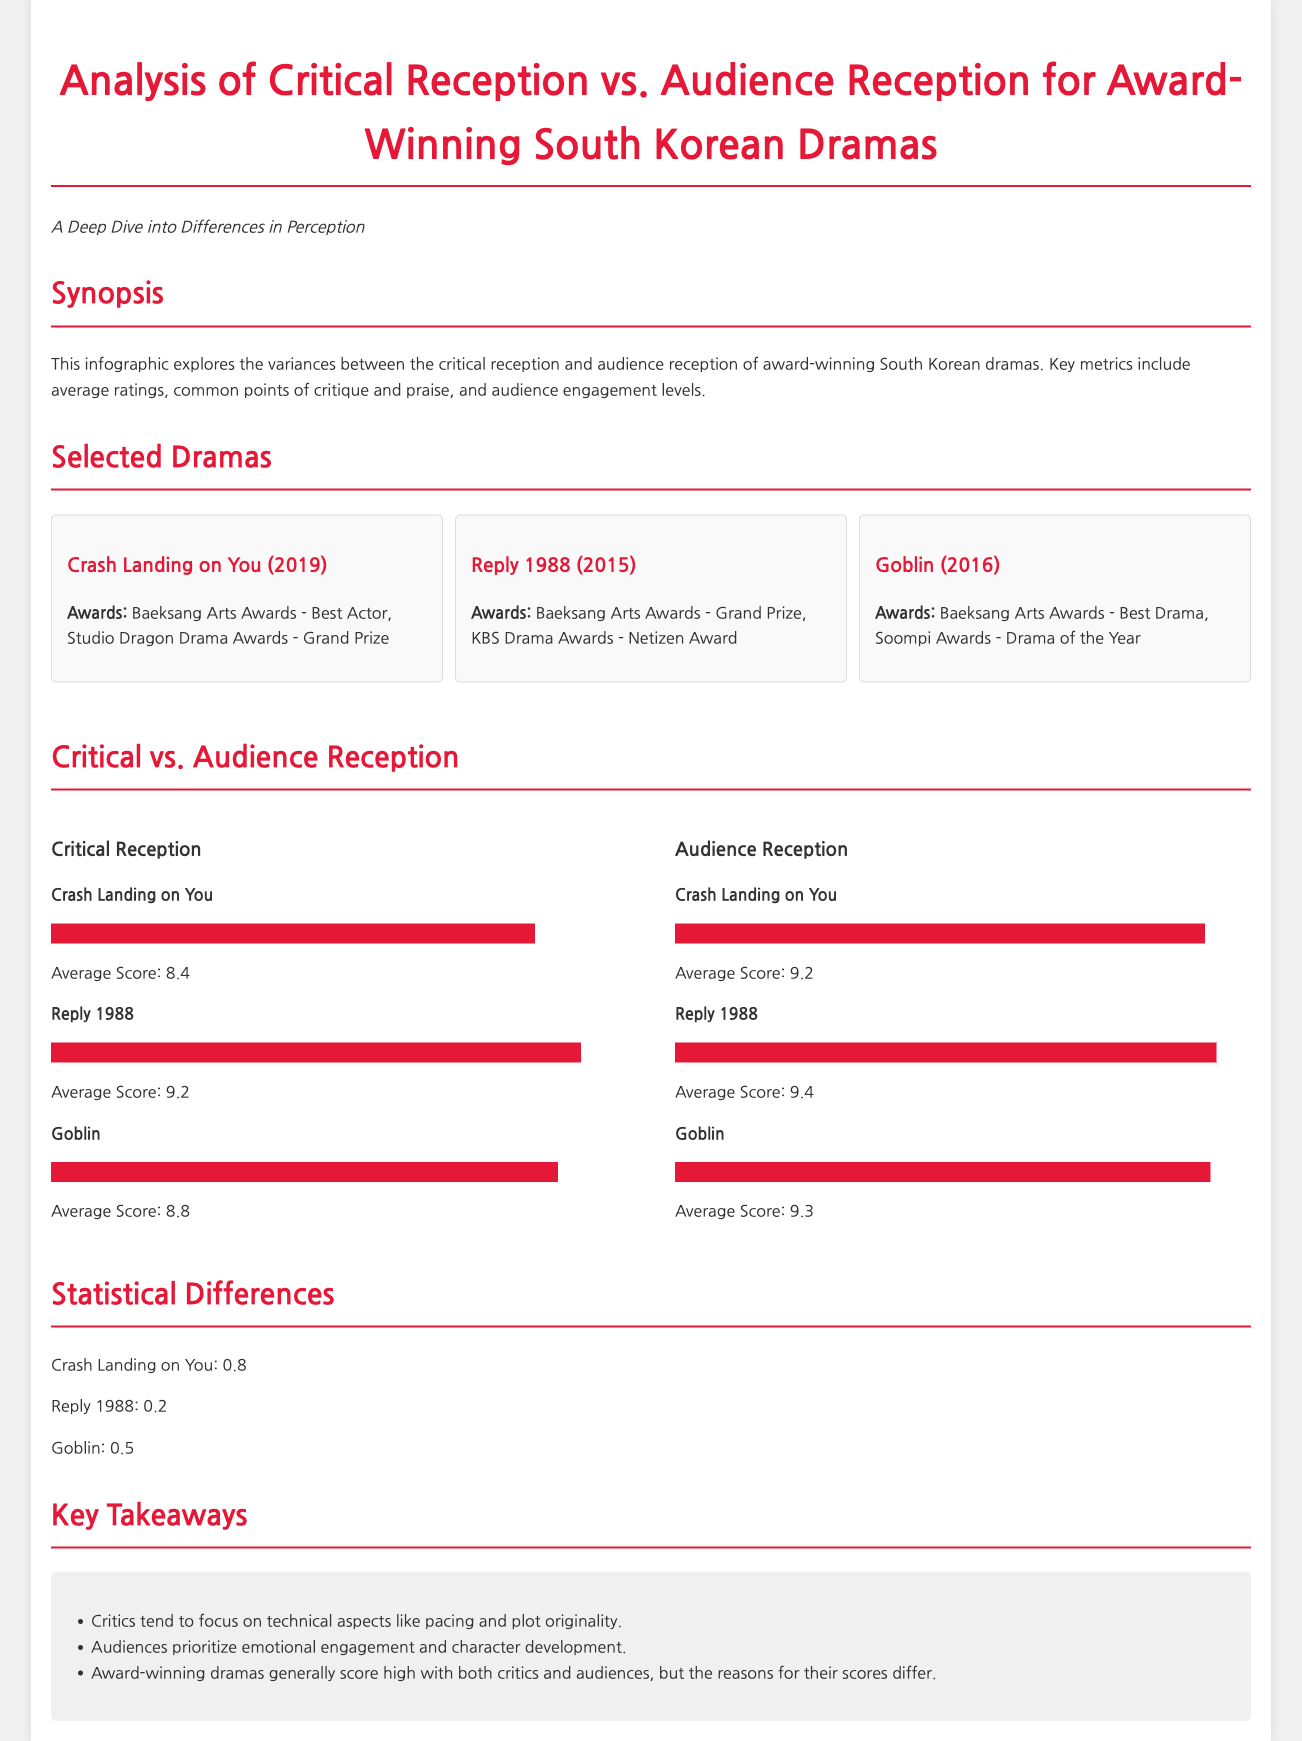what is the average score of "Crash Landing on You" from critics? The average score for "Crash Landing on You" from critics is listed in the document as 8.4.
Answer: 8.4 what is the average score of "Reply 1988" from audiences? The average score for "Reply 1988" from audiences is provided as 9.4 in the document.
Answer: 9.4 which drama received the Grand Prize at the Baeksang Arts Awards? "Reply 1988" is noted as receiving the Grand Prize at the Baeksang Arts Awards.
Answer: Reply 1988 what is the statistical difference for "Crash Landing on You"? The document states the statistical difference for "Crash Landing on You" is 0.8.
Answer: 0.8 which drama has the highest average score from critics? Among the dramas listed, "Reply 1988" has the highest average score from critics at 9.2.
Answer: Reply 1988 which aspect do critics focus on according to the key takeaways? Critics tend to focus on technical aspects like pacing and plot originality, as highlighted in the takeaways.
Answer: technical aspects what year did "Goblin" win the Baeksang Arts Awards for Best Drama? "Goblin" won the Baeksang Arts Awards for Best Drama in 2016, as indicated in the document.
Answer: 2016 how many dramas are analyzed in the infographic? The infographic analyzes three dramas in total, which are listed in the document.
Answer: three what is the common priority for audiences according to the takeaways? Audiences prioritize emotional engagement and character development, as mentioned in the takeaways.
Answer: emotional engagement 